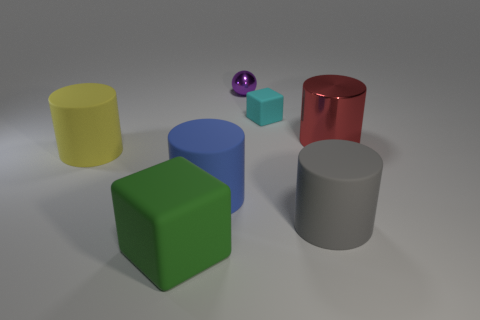Add 1 brown spheres. How many objects exist? 8 Subtract all blocks. How many objects are left? 5 Subtract all large cylinders. Subtract all metal balls. How many objects are left? 2 Add 7 small purple shiny objects. How many small purple shiny objects are left? 8 Add 7 large yellow matte things. How many large yellow matte things exist? 8 Subtract 1 yellow cylinders. How many objects are left? 6 